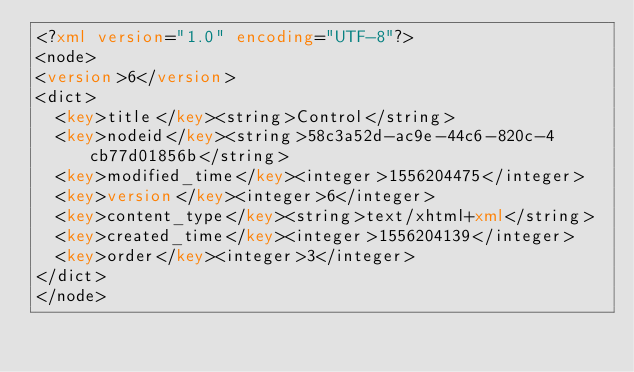<code> <loc_0><loc_0><loc_500><loc_500><_XML_><?xml version="1.0" encoding="UTF-8"?>
<node>
<version>6</version>
<dict>
  <key>title</key><string>Control</string>
  <key>nodeid</key><string>58c3a52d-ac9e-44c6-820c-4cb77d01856b</string>
  <key>modified_time</key><integer>1556204475</integer>
  <key>version</key><integer>6</integer>
  <key>content_type</key><string>text/xhtml+xml</string>
  <key>created_time</key><integer>1556204139</integer>
  <key>order</key><integer>3</integer>
</dict>
</node>
</code> 